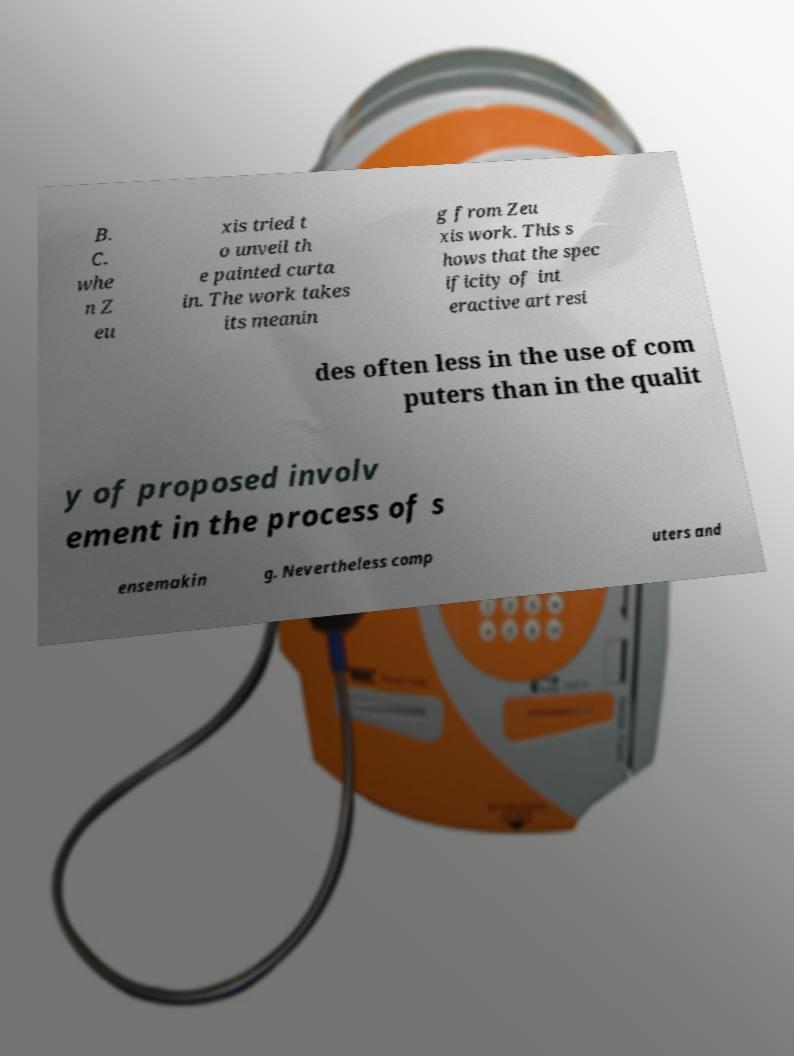Could you extract and type out the text from this image? B. C. whe n Z eu xis tried t o unveil th e painted curta in. The work takes its meanin g from Zeu xis work. This s hows that the spec ificity of int eractive art resi des often less in the use of com puters than in the qualit y of proposed involv ement in the process of s ensemakin g. Nevertheless comp uters and 